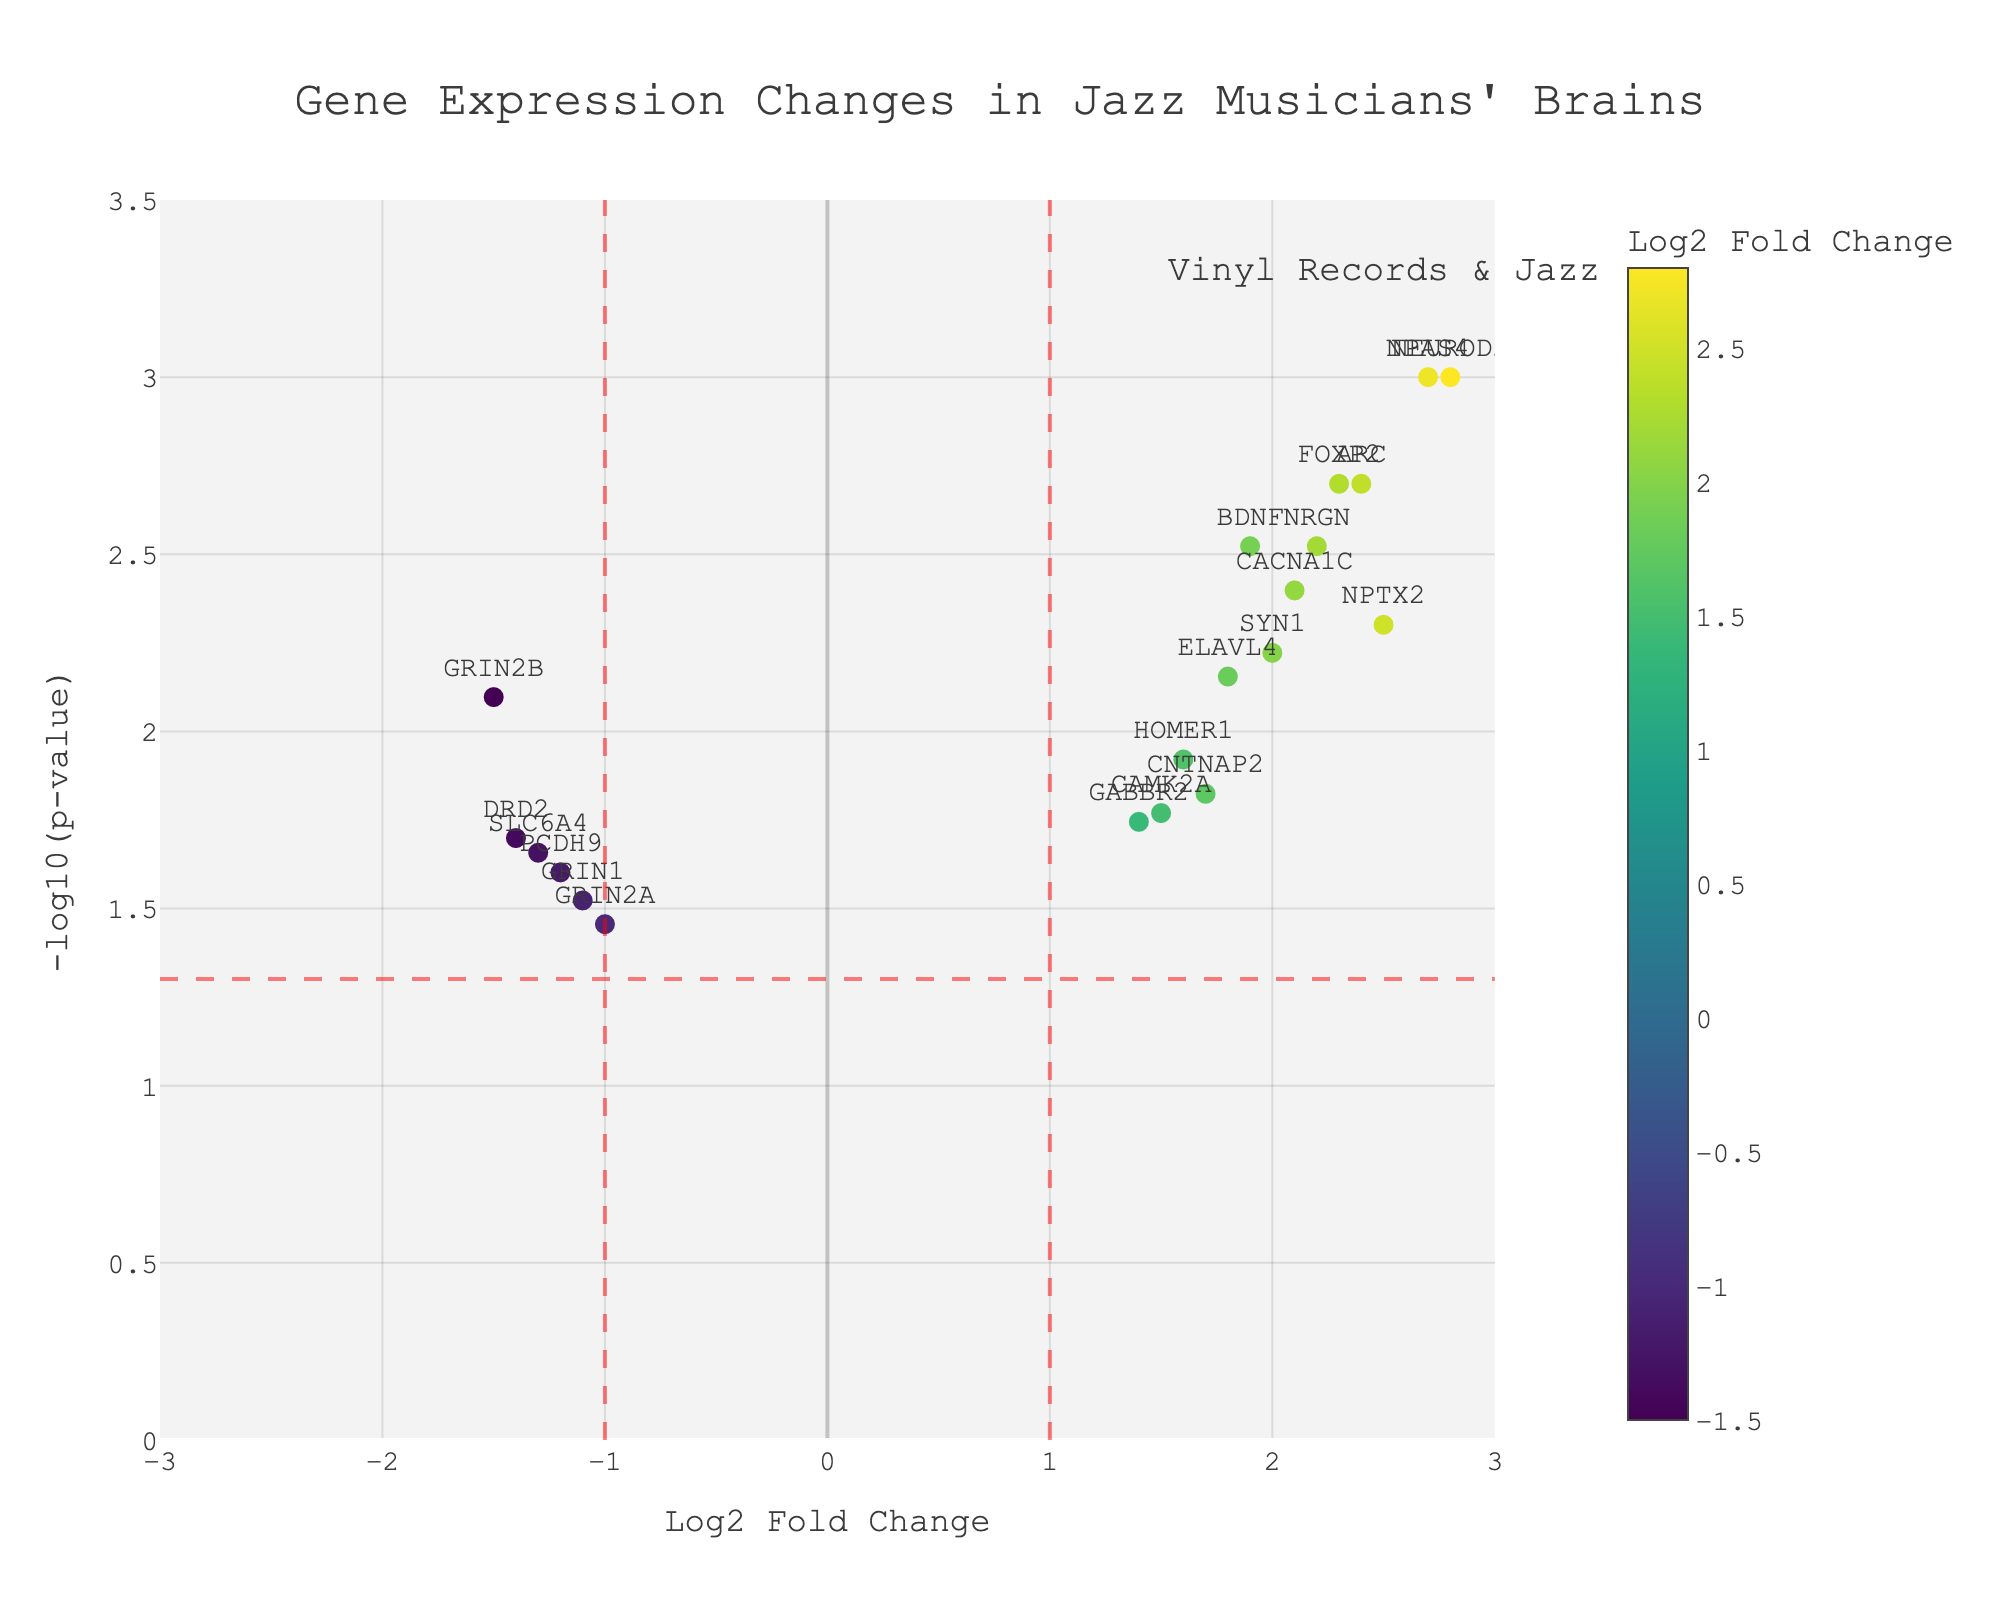What is the title of the plot? The title is displayed at the top of the plot and provides a brief overview of the figure's content.
Answer: Gene Expression Changes in Jazz Musicians' Brains Which gene has the highest Log2 Fold Change? By looking at the scatter plot, locate the point farthest to the right on the x-axis (positive Log2 Fold Change). The associated text label identifies the gene.
Answer: NEUROD2 How many genes have a -log10(p-value) greater than 2? Count the number of points that lie above the 2 mark on the y-axis.
Answer: 5 What color represents the highest Log2 Fold Change? The color bar indicates that darker colors (toward the yellow end of the Viridis scale) represent higher Log2 Fold Changes.
Answer: Yellow Which genes are significantly upregulated (Log2 Fold Change > 1) and have a p-value < 0.05? Identify genes on the right side of the vertical line at Log2 Fold Change = 1 that are also above the horizontal line at -log10(p) = 1.3010.
Answer: NEUROD2, BDNF, FOXP2, CNTNAP2, NPTX2, ELAVL4, CACNA1C, NPAS4, HOMER1, CAMK2A, SYN1, NRGN, ARC Which gene has the lowest log2 Fold Change and is considered downregulated with a significant p-value? Look for the point farthest to the left with a x < -1 and above the horizontal line at -log10(p) = 1.3010 on the x-axis. The gene label is identified.
Answer: GRIN2B What is the Log2 Fold Change value for GRIN2B? Identify the GRIN2B point on the scatter plot and read the corresponding x-axis value.
Answer: -1.5 How does the expression of GRIN2A compare with the expression of GRIN1? Locate the points for GRIN2A and GRIN1, compare their Log2 Fold Change values and note the differences.
Answer: GRIN2A is less downregulated than GRIN1 What is the significance threshold represented in this plot? Identify the horizontal dashed red line on the y-axis and reference its y-value. The value is -log10(p-value), indicating the threshold for statistical significance.
Answer: -log10(0.05) Which upregulated gene has a Log2 Fold Change close to 2.0? Scan the points on the right of the vertical line at Log2 Fold Change = 1 for those near the x = 2 line.
Answer: SYN1 